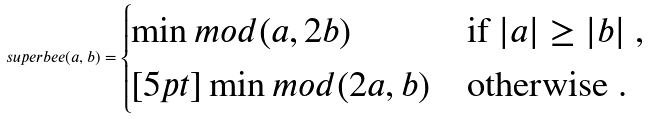Convert formula to latex. <formula><loc_0><loc_0><loc_500><loc_500>s u p e r b e e ( a , b ) = \begin{cases} \min m o d ( a , 2 b ) & \text {if } | a | \geq | b | \ , \\ [ 5 p t ] \min m o d ( 2 a , b ) & \text {otherwise .} \end{cases}</formula> 